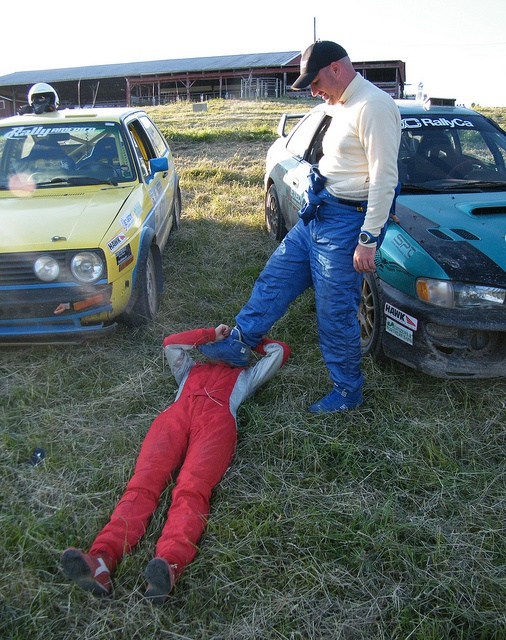Describe the objects in this image and their specific colors. I can see car in white, lightgray, gray, blue, and black tones, car in white, black, navy, blue, and gray tones, people in white, navy, blue, and black tones, people in white, brown, black, and maroon tones, and tie in white, gray, black, and darkblue tones in this image. 